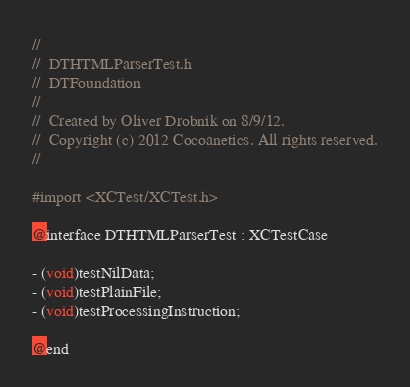Convert code to text. <code><loc_0><loc_0><loc_500><loc_500><_C_>//
//  DTHTMLParserTest.h
//  DTFoundation
//
//  Created by Oliver Drobnik on 8/9/12.
//  Copyright (c) 2012 Cocoanetics. All rights reserved.
//

#import <XCTest/XCTest.h>

@interface DTHTMLParserTest : XCTestCase

- (void)testNilData;
- (void)testPlainFile;
- (void)testProcessingInstruction;

@end
</code> 